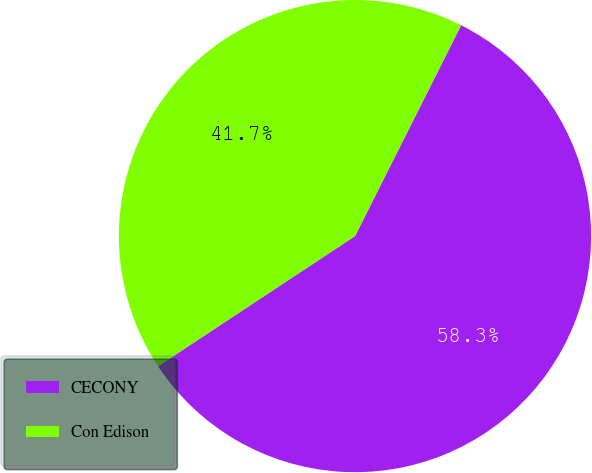Convert chart. <chart><loc_0><loc_0><loc_500><loc_500><pie_chart><fcel>CECONY<fcel>Con Edison<nl><fcel>58.29%<fcel>41.71%<nl></chart> 